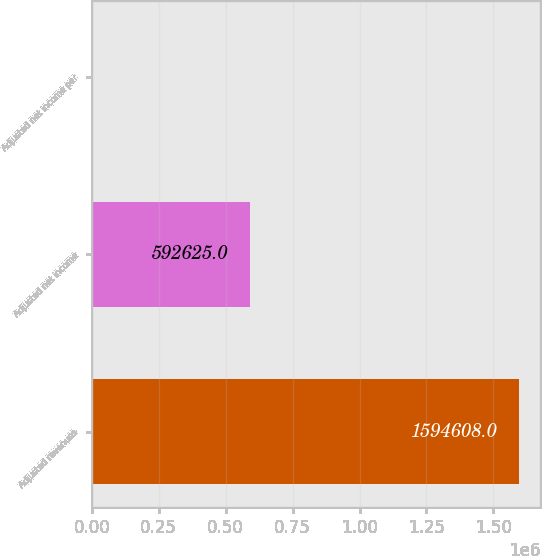<chart> <loc_0><loc_0><loc_500><loc_500><bar_chart><fcel>Adjusted revenues<fcel>Adjusted net income<fcel>Adjusted net income per<nl><fcel>1.59461e+06<fcel>592625<fcel>6.3<nl></chart> 